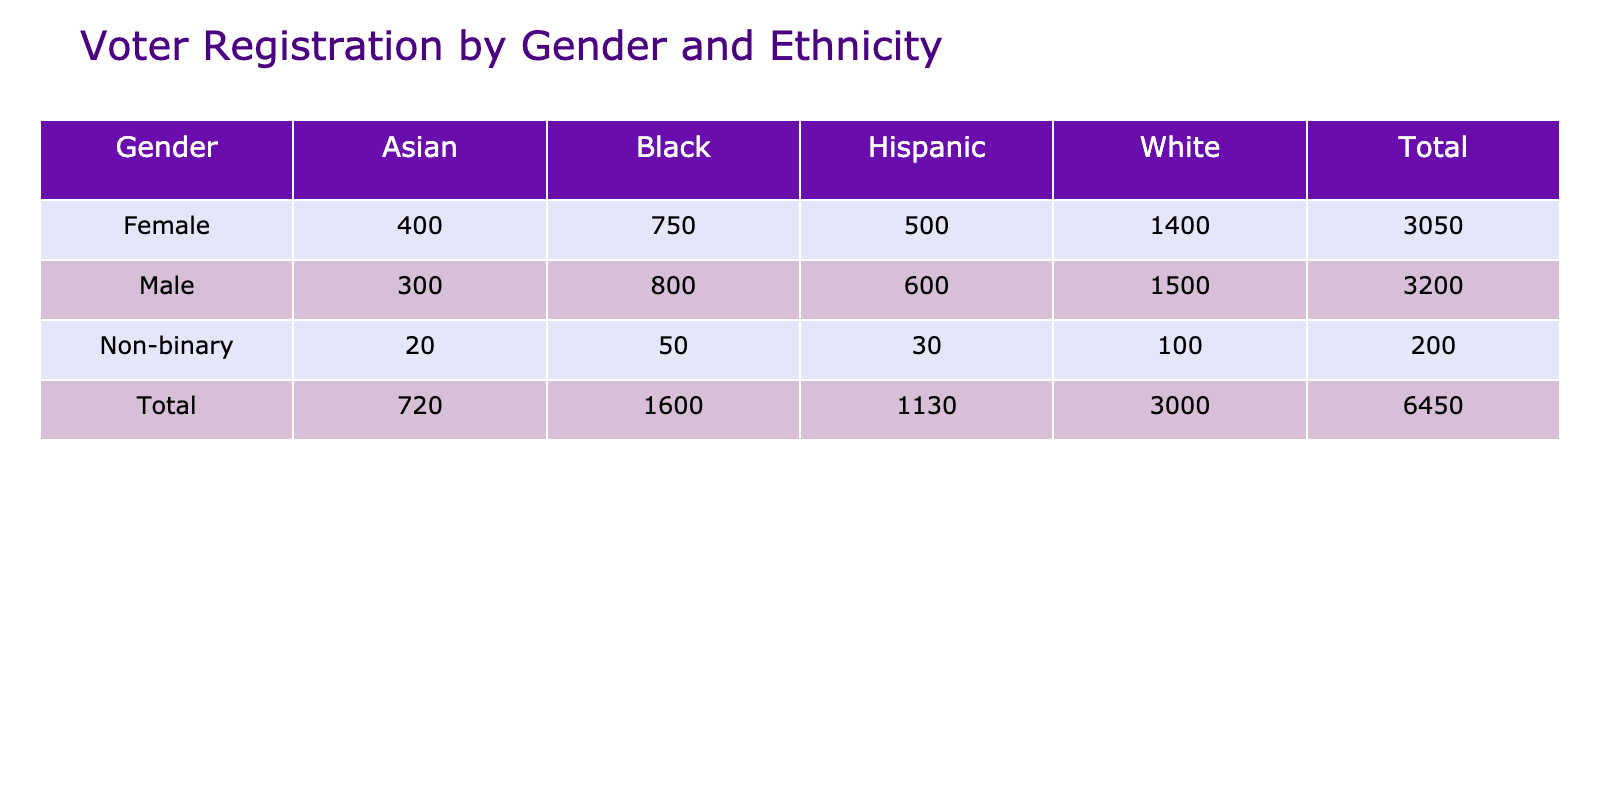What is the total number of voter registrations for Female candidates? To find this, we only need to look at the row for Female in the table. The total number of registrations for Female candidates is the sum of White (1400), Black (750), Hispanic (500), and Asian (400), which equals 1400 + 750 + 500 + 400 = 3050.
Answer: 3050 Which gender has the highest number of registrations among Hispanic voters? We can examine the Hispanic column for all genders. Males have 600 registrations, while Females have 500 registrations, and Non-binary individuals have 30 registrations. Therefore, Males have the highest number of registrations among Hispanic voters.
Answer: Male Are there more Male registrations or Female registrations in total? To compare the totals, we sum the registrations for both genders. Males have 1500 + 800 + 600 + 300 = 3200, and Females have 1400 + 750 + 500 + 400 = 3050. Since 3200 > 3050, Males have more registrations.
Answer: Yes What is the difference in the total number of registrations between White and Black Male voters? First, we find the total registrations for White Male voters, which is 1500, and for Black Male voters, which is 800. The difference is 1500 - 800 = 700.
Answer: 700 What proportion of the total registrations does the Non-binary category represent? First, we calculate the total number of registrations: 1500 + 800 + 600 + 300 + 1400 + 750 + 500 + 400 + 100 + 50 + 30 + 20 = 5050. Next, we sum the Non-binary registrations: 100 + 50 + 30 + 20 = 200. The proportion of Non-binary registrations is 200 / 5050, which simplifies to about 0.0396 or 3.96%.
Answer: 3.96% Is the number of Asian registrations higher for Males compared to Females? We can check the Asian column for both genders. Males have 300 registrations in total, while Females have 400. Since 300 < 400, the statement is false.
Answer: No What is the total number of voter registrations for all ethnicities combined for Non-binary individuals? Looking at the row for Non-binary in the table, we add their registrations: White (100), Black (50), Hispanic (30), and Asian (20). The total is 100 + 50 + 30 + 20 = 200.
Answer: 200 Which ethnic group has the lowest number of registrations among all genders? We check each ethnic group’s total across all genders. For the Asian group, we have 300 (Male) + 400 (Female) + 20 (Non-binary) = 720, for the Black group it’s 800 + 750 + 50 = 1600, Hispanic adds up to 600 + 500 + 30 = 1130, and White totals to 1500 + 1400 + 100 = 3000. The Asian group has the lowest total registrations at 720.
Answer: Asian 